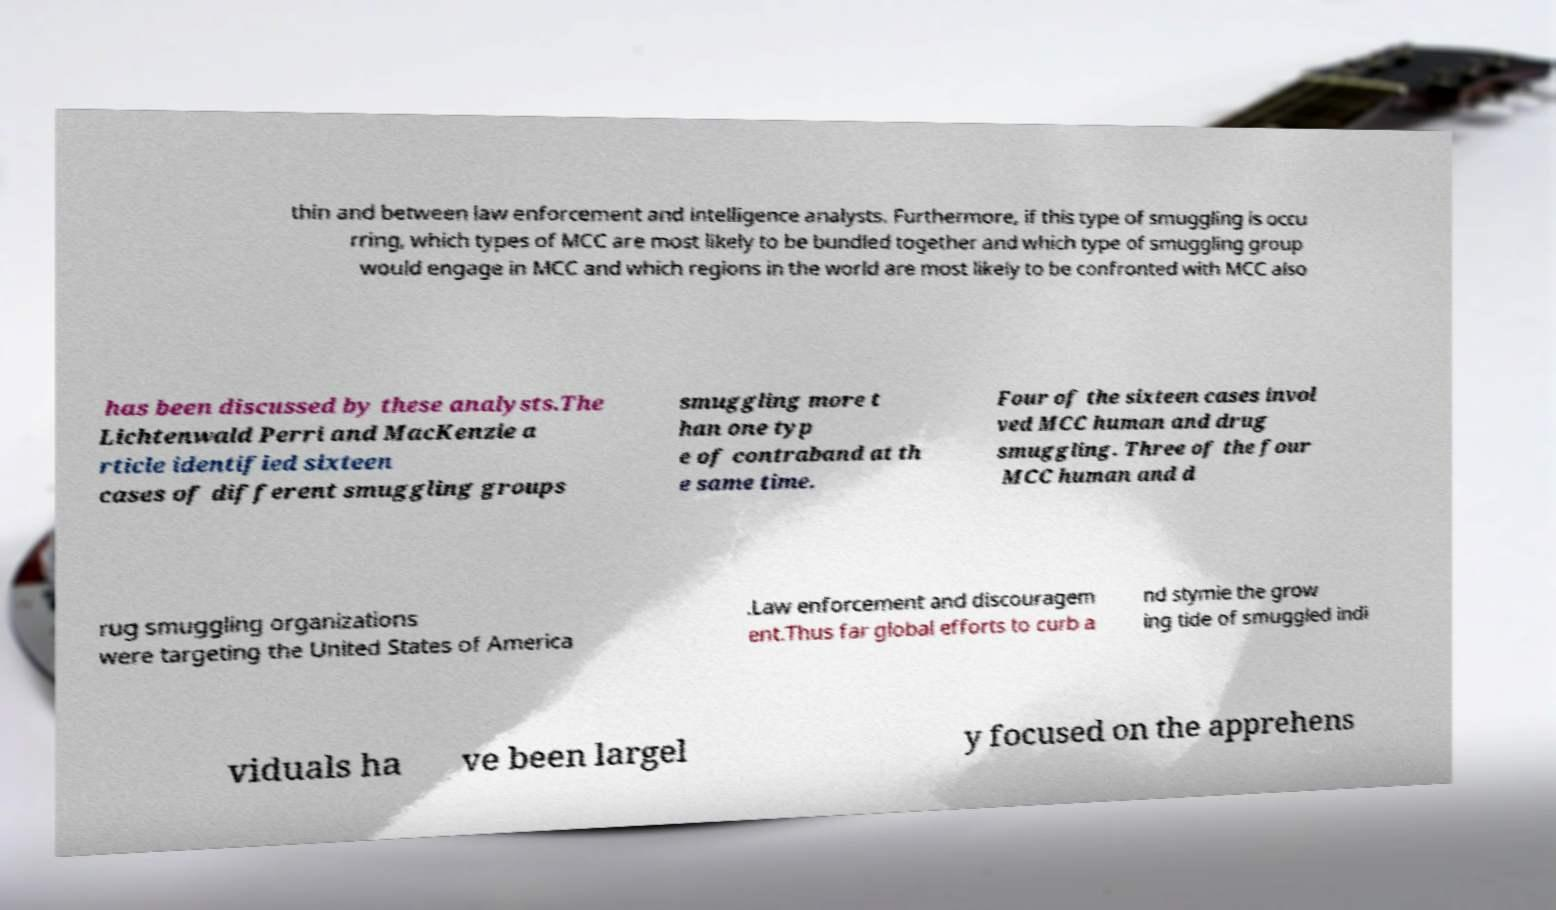Could you assist in decoding the text presented in this image and type it out clearly? thin and between law enforcement and intelligence analysts. Furthermore, if this type of smuggling is occu rring, which types of MCC are most likely to be bundled together and which type of smuggling group would engage in MCC and which regions in the world are most likely to be confronted with MCC also has been discussed by these analysts.The Lichtenwald Perri and MacKenzie a rticle identified sixteen cases of different smuggling groups smuggling more t han one typ e of contraband at th e same time. Four of the sixteen cases invol ved MCC human and drug smuggling. Three of the four MCC human and d rug smuggling organizations were targeting the United States of America .Law enforcement and discouragem ent.Thus far global efforts to curb a nd stymie the grow ing tide of smuggled indi viduals ha ve been largel y focused on the apprehens 